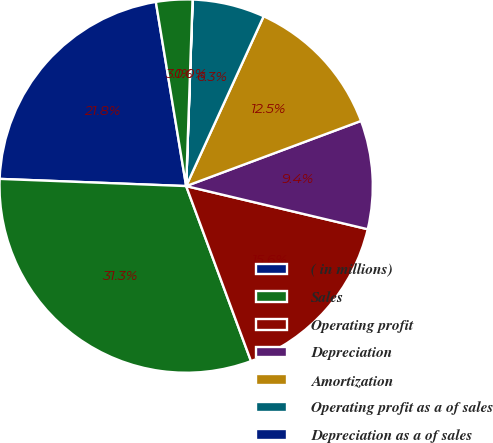<chart> <loc_0><loc_0><loc_500><loc_500><pie_chart><fcel>( in millions)<fcel>Sales<fcel>Operating profit<fcel>Depreciation<fcel>Amortization<fcel>Operating profit as a of sales<fcel>Depreciation as a of sales<fcel>Amortization as a of sales<nl><fcel>21.79%<fcel>31.26%<fcel>15.64%<fcel>9.39%<fcel>12.51%<fcel>6.26%<fcel>0.01%<fcel>3.14%<nl></chart> 